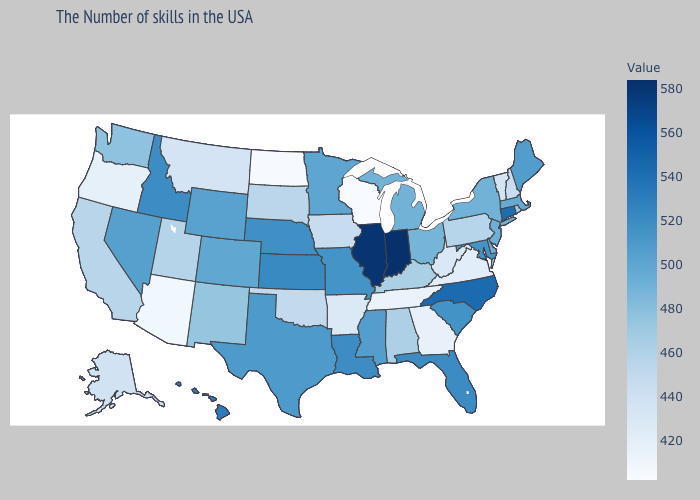Does Indiana have the highest value in the USA?
Concise answer only. Yes. Which states hav the highest value in the MidWest?
Be succinct. Indiana. Which states have the lowest value in the West?
Short answer required. Arizona. Does Alaska have a lower value than Tennessee?
Concise answer only. No. Among the states that border South Dakota , does North Dakota have the lowest value?
Keep it brief. Yes. Which states have the lowest value in the USA?
Write a very short answer. Wisconsin. 